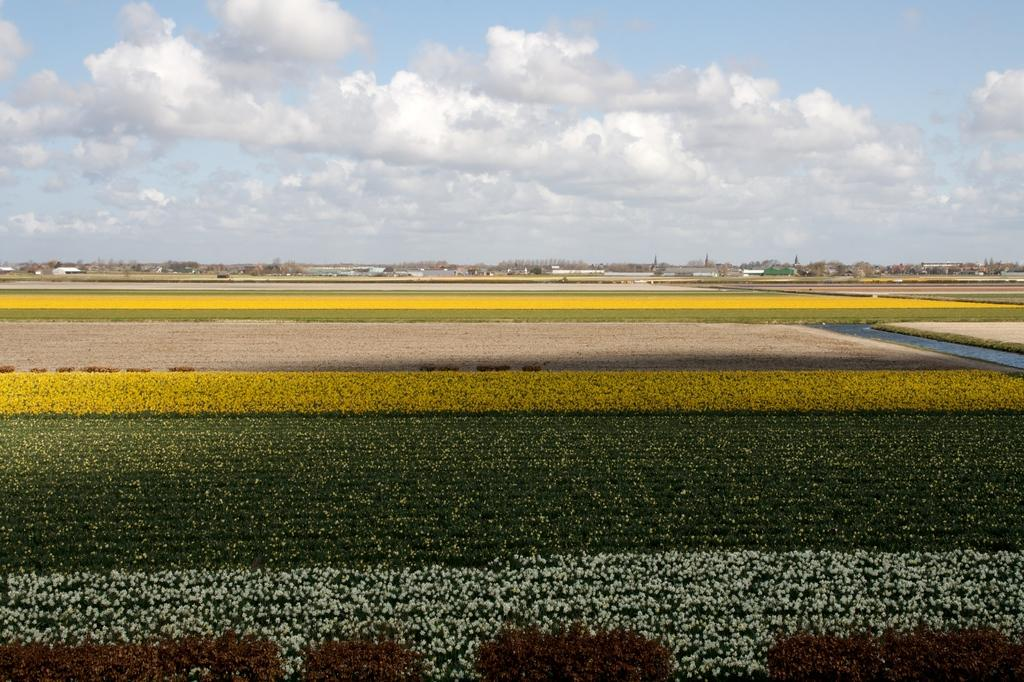What type of vegetation is present in the image? There is grass in the image. What else can be seen in the image besides grass? There are trees and buildings in the image. What is visible at the top of the image? Clouds and the sky are visible at the top of the image. What type of coil can be seen in the image? There is no coil present in the image. What is the taste of the grass in the image? The taste of the grass cannot be determined from the image, as it is a visual representation and not a sensory experience. 